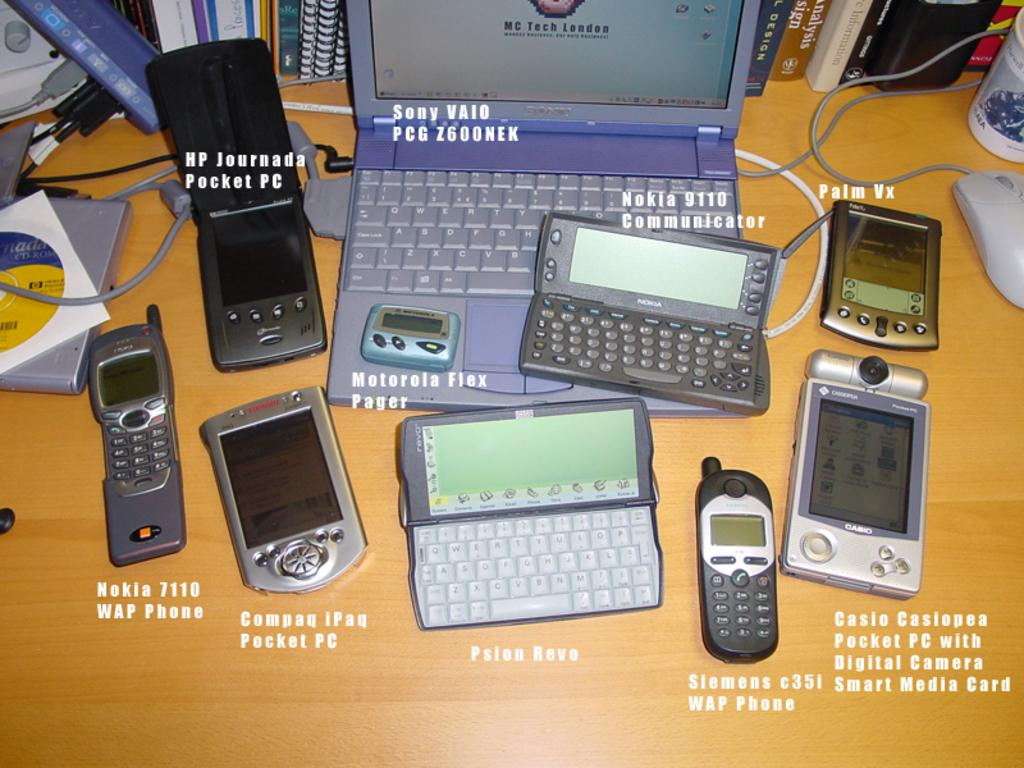<image>
Offer a succinct explanation of the picture presented. A table full of electronic devices are from brands like Casio, Nokia, Hp, and Sony. 